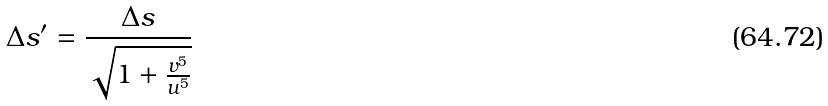<formula> <loc_0><loc_0><loc_500><loc_500>\Delta s ^ { \prime } = \frac { \Delta s } { \sqrt { 1 + \frac { v ^ { 5 } } { u ^ { 5 } } } }</formula> 